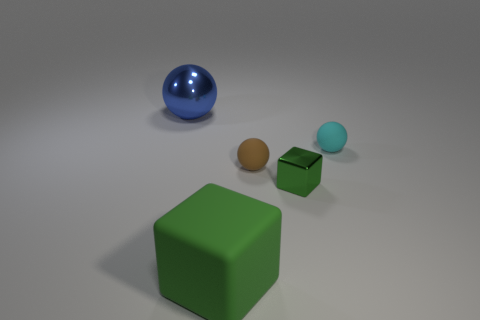Subtract all cyan spheres. How many spheres are left? 2 Subtract all blue spheres. How many spheres are left? 2 Add 3 yellow shiny cylinders. How many objects exist? 8 Subtract 2 balls. How many balls are left? 1 Subtract all blocks. How many objects are left? 3 Subtract all brown balls. Subtract all blue cylinders. How many balls are left? 2 Subtract all red blocks. How many blue spheres are left? 1 Subtract all big matte objects. Subtract all small brown things. How many objects are left? 3 Add 5 large green matte cubes. How many large green matte cubes are left? 6 Add 5 tiny brown objects. How many tiny brown objects exist? 6 